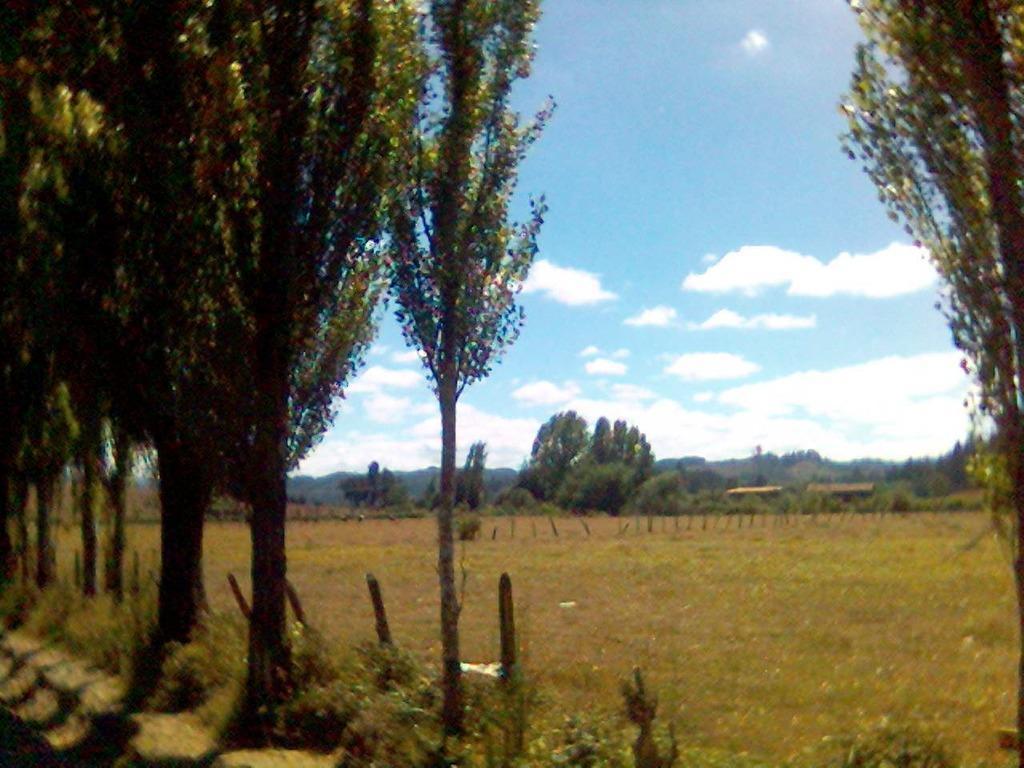How would you summarize this image in a sentence or two? In this image, we can see some trees and plants. There is a sky at the top of the image. 